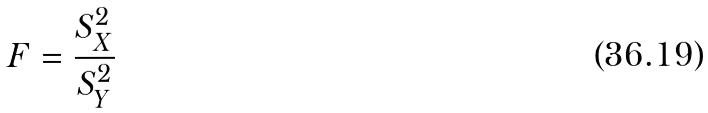<formula> <loc_0><loc_0><loc_500><loc_500>F = \frac { S _ { X } ^ { 2 } } { S _ { Y } ^ { 2 } }</formula> 